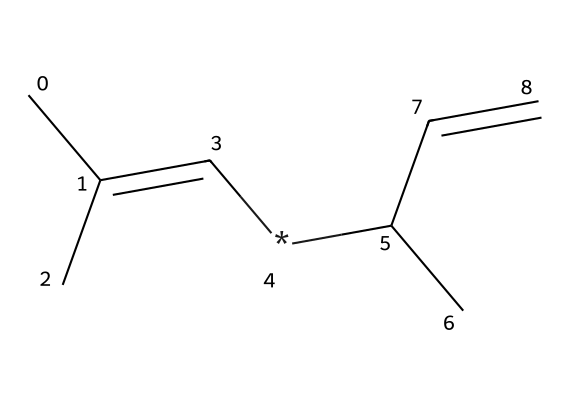What is the primary functional group present in this chemical? Based on the SMILES notation, the structure reveals the presence of a double bond (C=C), indicating that this compound contains alkenes as its functional group.
Answer: alkene How many carbon atoms are present in the molecule? Counting the carbon symbols (C) in the SMILES representation, there are a total of six carbon atoms present in the molecular structure.
Answer: six What type of polymer can this chemical be used to synthesize? This chemical structure corresponds to a rubber-like compound; therefore, it can be used to synthesize synthetic rubber, which is known for its elasticity and usage in vehicle tires.
Answer: synthetic rubber What is the degree of unsaturation in this molecule? The degree of unsaturation can be determined by counting the number of double bonds and rings in the structure. The presence of two double bonds in the SMILES indicates a degree of unsaturation of two.
Answer: two What is the general characteristic of the hydrocarbon chain in this molecule? The hydrocarbon chain in this molecule includes branching and unsaturated components due to the presence of both single and double bonds, which makes it flexible yet strong, characteristic of rubber-like materials.
Answer: flexible Which component contributes to the rubber-like property in this chemical? The presence of the multiple double bonds (C=C) and branched structure contributes significantly to the flexible and elastic properties of the material, which is typical for rubber compounds.
Answer: double bonds 